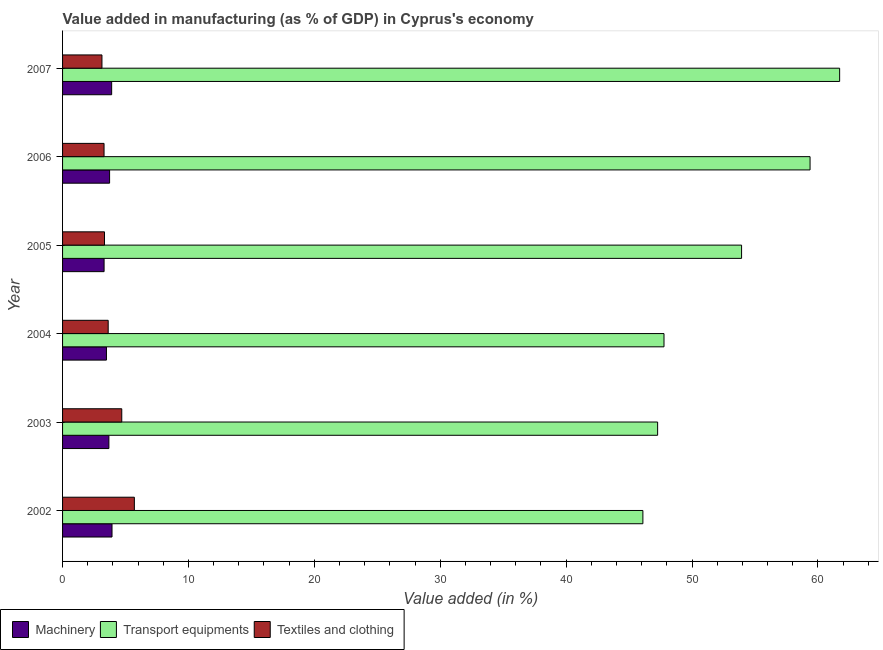How many groups of bars are there?
Provide a short and direct response. 6. Are the number of bars on each tick of the Y-axis equal?
Your answer should be very brief. Yes. What is the value added in manufacturing machinery in 2007?
Give a very brief answer. 3.9. Across all years, what is the maximum value added in manufacturing machinery?
Ensure brevity in your answer.  3.93. Across all years, what is the minimum value added in manufacturing machinery?
Your answer should be very brief. 3.3. In which year was the value added in manufacturing machinery maximum?
Your answer should be very brief. 2002. What is the total value added in manufacturing transport equipments in the graph?
Keep it short and to the point. 316.18. What is the difference between the value added in manufacturing machinery in 2002 and that in 2004?
Provide a short and direct response. 0.44. What is the difference between the value added in manufacturing machinery in 2002 and the value added in manufacturing textile and clothing in 2006?
Keep it short and to the point. 0.63. What is the average value added in manufacturing textile and clothing per year?
Keep it short and to the point. 3.96. In the year 2004, what is the difference between the value added in manufacturing transport equipments and value added in manufacturing textile and clothing?
Provide a succinct answer. 44.15. What is the ratio of the value added in manufacturing machinery in 2005 to that in 2007?
Provide a short and direct response. 0.85. Is the value added in manufacturing machinery in 2003 less than that in 2005?
Provide a short and direct response. No. Is the difference between the value added in manufacturing transport equipments in 2002 and 2005 greater than the difference between the value added in manufacturing machinery in 2002 and 2005?
Your answer should be very brief. No. What is the difference between the highest and the lowest value added in manufacturing transport equipments?
Your answer should be very brief. 15.63. In how many years, is the value added in manufacturing transport equipments greater than the average value added in manufacturing transport equipments taken over all years?
Offer a very short reply. 3. Is the sum of the value added in manufacturing machinery in 2002 and 2003 greater than the maximum value added in manufacturing textile and clothing across all years?
Provide a short and direct response. Yes. What does the 2nd bar from the top in 2007 represents?
Your answer should be very brief. Transport equipments. What does the 1st bar from the bottom in 2007 represents?
Ensure brevity in your answer.  Machinery. Is it the case that in every year, the sum of the value added in manufacturing machinery and value added in manufacturing transport equipments is greater than the value added in manufacturing textile and clothing?
Your response must be concise. Yes. How many bars are there?
Your answer should be compact. 18. Are all the bars in the graph horizontal?
Provide a short and direct response. Yes. How many years are there in the graph?
Provide a short and direct response. 6. What is the difference between two consecutive major ticks on the X-axis?
Give a very brief answer. 10. Does the graph contain any zero values?
Make the answer very short. No. Does the graph contain grids?
Provide a short and direct response. No. What is the title of the graph?
Make the answer very short. Value added in manufacturing (as % of GDP) in Cyprus's economy. What is the label or title of the X-axis?
Give a very brief answer. Value added (in %). What is the label or title of the Y-axis?
Provide a succinct answer. Year. What is the Value added (in %) in Machinery in 2002?
Keep it short and to the point. 3.93. What is the Value added (in %) of Transport equipments in 2002?
Offer a very short reply. 46.1. What is the Value added (in %) in Textiles and clothing in 2002?
Give a very brief answer. 5.7. What is the Value added (in %) of Machinery in 2003?
Offer a terse response. 3.68. What is the Value added (in %) in Transport equipments in 2003?
Provide a succinct answer. 47.27. What is the Value added (in %) of Textiles and clothing in 2003?
Your answer should be compact. 4.7. What is the Value added (in %) in Machinery in 2004?
Offer a very short reply. 3.49. What is the Value added (in %) of Transport equipments in 2004?
Provide a short and direct response. 47.78. What is the Value added (in %) of Textiles and clothing in 2004?
Offer a terse response. 3.62. What is the Value added (in %) in Machinery in 2005?
Your answer should be compact. 3.3. What is the Value added (in %) of Transport equipments in 2005?
Provide a short and direct response. 53.94. What is the Value added (in %) of Textiles and clothing in 2005?
Provide a short and direct response. 3.33. What is the Value added (in %) of Machinery in 2006?
Provide a succinct answer. 3.74. What is the Value added (in %) in Transport equipments in 2006?
Offer a very short reply. 59.38. What is the Value added (in %) in Textiles and clothing in 2006?
Provide a succinct answer. 3.29. What is the Value added (in %) in Machinery in 2007?
Provide a short and direct response. 3.9. What is the Value added (in %) in Transport equipments in 2007?
Ensure brevity in your answer.  61.73. What is the Value added (in %) of Textiles and clothing in 2007?
Give a very brief answer. 3.13. Across all years, what is the maximum Value added (in %) in Machinery?
Ensure brevity in your answer.  3.93. Across all years, what is the maximum Value added (in %) of Transport equipments?
Give a very brief answer. 61.73. Across all years, what is the maximum Value added (in %) of Textiles and clothing?
Your response must be concise. 5.7. Across all years, what is the minimum Value added (in %) in Machinery?
Your answer should be very brief. 3.3. Across all years, what is the minimum Value added (in %) in Transport equipments?
Provide a short and direct response. 46.1. Across all years, what is the minimum Value added (in %) in Textiles and clothing?
Provide a succinct answer. 3.13. What is the total Value added (in %) of Machinery in the graph?
Keep it short and to the point. 22.03. What is the total Value added (in %) of Transport equipments in the graph?
Provide a short and direct response. 316.18. What is the total Value added (in %) of Textiles and clothing in the graph?
Provide a succinct answer. 23.78. What is the difference between the Value added (in %) of Machinery in 2002 and that in 2003?
Your answer should be very brief. 0.25. What is the difference between the Value added (in %) of Transport equipments in 2002 and that in 2003?
Give a very brief answer. -1.17. What is the difference between the Value added (in %) in Machinery in 2002 and that in 2004?
Ensure brevity in your answer.  0.44. What is the difference between the Value added (in %) in Transport equipments in 2002 and that in 2004?
Make the answer very short. -1.68. What is the difference between the Value added (in %) in Textiles and clothing in 2002 and that in 2004?
Your response must be concise. 2.08. What is the difference between the Value added (in %) in Machinery in 2002 and that in 2005?
Keep it short and to the point. 0.63. What is the difference between the Value added (in %) in Transport equipments in 2002 and that in 2005?
Your response must be concise. -7.84. What is the difference between the Value added (in %) of Textiles and clothing in 2002 and that in 2005?
Give a very brief answer. 2.37. What is the difference between the Value added (in %) in Machinery in 2002 and that in 2006?
Ensure brevity in your answer.  0.19. What is the difference between the Value added (in %) of Transport equipments in 2002 and that in 2006?
Give a very brief answer. -13.28. What is the difference between the Value added (in %) in Textiles and clothing in 2002 and that in 2006?
Make the answer very short. 2.41. What is the difference between the Value added (in %) in Machinery in 2002 and that in 2007?
Provide a short and direct response. 0.03. What is the difference between the Value added (in %) of Transport equipments in 2002 and that in 2007?
Your answer should be very brief. -15.63. What is the difference between the Value added (in %) in Textiles and clothing in 2002 and that in 2007?
Provide a succinct answer. 2.58. What is the difference between the Value added (in %) in Machinery in 2003 and that in 2004?
Your response must be concise. 0.19. What is the difference between the Value added (in %) in Transport equipments in 2003 and that in 2004?
Your response must be concise. -0.51. What is the difference between the Value added (in %) of Textiles and clothing in 2003 and that in 2004?
Your answer should be very brief. 1.08. What is the difference between the Value added (in %) in Machinery in 2003 and that in 2005?
Give a very brief answer. 0.38. What is the difference between the Value added (in %) in Transport equipments in 2003 and that in 2005?
Offer a very short reply. -6.67. What is the difference between the Value added (in %) in Textiles and clothing in 2003 and that in 2005?
Ensure brevity in your answer.  1.37. What is the difference between the Value added (in %) of Machinery in 2003 and that in 2006?
Provide a short and direct response. -0.06. What is the difference between the Value added (in %) in Transport equipments in 2003 and that in 2006?
Provide a short and direct response. -12.11. What is the difference between the Value added (in %) in Textiles and clothing in 2003 and that in 2006?
Offer a terse response. 1.41. What is the difference between the Value added (in %) in Machinery in 2003 and that in 2007?
Offer a very short reply. -0.22. What is the difference between the Value added (in %) in Transport equipments in 2003 and that in 2007?
Your answer should be compact. -14.46. What is the difference between the Value added (in %) in Textiles and clothing in 2003 and that in 2007?
Provide a succinct answer. 1.57. What is the difference between the Value added (in %) in Machinery in 2004 and that in 2005?
Your response must be concise. 0.19. What is the difference between the Value added (in %) of Transport equipments in 2004 and that in 2005?
Your answer should be very brief. -6.16. What is the difference between the Value added (in %) of Textiles and clothing in 2004 and that in 2005?
Offer a very short reply. 0.29. What is the difference between the Value added (in %) of Machinery in 2004 and that in 2006?
Provide a succinct answer. -0.25. What is the difference between the Value added (in %) in Transport equipments in 2004 and that in 2006?
Your answer should be compact. -11.6. What is the difference between the Value added (in %) of Textiles and clothing in 2004 and that in 2006?
Your answer should be very brief. 0.33. What is the difference between the Value added (in %) of Machinery in 2004 and that in 2007?
Your answer should be compact. -0.41. What is the difference between the Value added (in %) of Transport equipments in 2004 and that in 2007?
Make the answer very short. -13.95. What is the difference between the Value added (in %) of Textiles and clothing in 2004 and that in 2007?
Provide a succinct answer. 0.5. What is the difference between the Value added (in %) in Machinery in 2005 and that in 2006?
Ensure brevity in your answer.  -0.44. What is the difference between the Value added (in %) of Transport equipments in 2005 and that in 2006?
Your answer should be compact. -5.44. What is the difference between the Value added (in %) in Textiles and clothing in 2005 and that in 2006?
Offer a terse response. 0.04. What is the difference between the Value added (in %) in Machinery in 2005 and that in 2007?
Your answer should be very brief. -0.6. What is the difference between the Value added (in %) in Transport equipments in 2005 and that in 2007?
Make the answer very short. -7.79. What is the difference between the Value added (in %) in Textiles and clothing in 2005 and that in 2007?
Your answer should be very brief. 0.2. What is the difference between the Value added (in %) in Machinery in 2006 and that in 2007?
Your answer should be compact. -0.16. What is the difference between the Value added (in %) of Transport equipments in 2006 and that in 2007?
Your response must be concise. -2.35. What is the difference between the Value added (in %) of Textiles and clothing in 2006 and that in 2007?
Your answer should be compact. 0.17. What is the difference between the Value added (in %) in Machinery in 2002 and the Value added (in %) in Transport equipments in 2003?
Offer a terse response. -43.34. What is the difference between the Value added (in %) in Machinery in 2002 and the Value added (in %) in Textiles and clothing in 2003?
Provide a short and direct response. -0.77. What is the difference between the Value added (in %) in Transport equipments in 2002 and the Value added (in %) in Textiles and clothing in 2003?
Provide a succinct answer. 41.4. What is the difference between the Value added (in %) in Machinery in 2002 and the Value added (in %) in Transport equipments in 2004?
Provide a succinct answer. -43.85. What is the difference between the Value added (in %) in Machinery in 2002 and the Value added (in %) in Textiles and clothing in 2004?
Your answer should be compact. 0.3. What is the difference between the Value added (in %) of Transport equipments in 2002 and the Value added (in %) of Textiles and clothing in 2004?
Provide a succinct answer. 42.47. What is the difference between the Value added (in %) in Machinery in 2002 and the Value added (in %) in Transport equipments in 2005?
Offer a terse response. -50.01. What is the difference between the Value added (in %) in Machinery in 2002 and the Value added (in %) in Textiles and clothing in 2005?
Provide a succinct answer. 0.6. What is the difference between the Value added (in %) of Transport equipments in 2002 and the Value added (in %) of Textiles and clothing in 2005?
Your answer should be very brief. 42.77. What is the difference between the Value added (in %) in Machinery in 2002 and the Value added (in %) in Transport equipments in 2006?
Make the answer very short. -55.45. What is the difference between the Value added (in %) in Machinery in 2002 and the Value added (in %) in Textiles and clothing in 2006?
Keep it short and to the point. 0.63. What is the difference between the Value added (in %) of Transport equipments in 2002 and the Value added (in %) of Textiles and clothing in 2006?
Provide a succinct answer. 42.8. What is the difference between the Value added (in %) of Machinery in 2002 and the Value added (in %) of Transport equipments in 2007?
Offer a terse response. -57.8. What is the difference between the Value added (in %) in Machinery in 2002 and the Value added (in %) in Textiles and clothing in 2007?
Offer a very short reply. 0.8. What is the difference between the Value added (in %) in Transport equipments in 2002 and the Value added (in %) in Textiles and clothing in 2007?
Provide a short and direct response. 42.97. What is the difference between the Value added (in %) of Machinery in 2003 and the Value added (in %) of Transport equipments in 2004?
Provide a succinct answer. -44.1. What is the difference between the Value added (in %) in Machinery in 2003 and the Value added (in %) in Textiles and clothing in 2004?
Give a very brief answer. 0.06. What is the difference between the Value added (in %) of Transport equipments in 2003 and the Value added (in %) of Textiles and clothing in 2004?
Offer a terse response. 43.64. What is the difference between the Value added (in %) of Machinery in 2003 and the Value added (in %) of Transport equipments in 2005?
Ensure brevity in your answer.  -50.26. What is the difference between the Value added (in %) of Machinery in 2003 and the Value added (in %) of Textiles and clothing in 2005?
Offer a terse response. 0.35. What is the difference between the Value added (in %) in Transport equipments in 2003 and the Value added (in %) in Textiles and clothing in 2005?
Keep it short and to the point. 43.94. What is the difference between the Value added (in %) of Machinery in 2003 and the Value added (in %) of Transport equipments in 2006?
Keep it short and to the point. -55.7. What is the difference between the Value added (in %) in Machinery in 2003 and the Value added (in %) in Textiles and clothing in 2006?
Keep it short and to the point. 0.38. What is the difference between the Value added (in %) in Transport equipments in 2003 and the Value added (in %) in Textiles and clothing in 2006?
Give a very brief answer. 43.97. What is the difference between the Value added (in %) of Machinery in 2003 and the Value added (in %) of Transport equipments in 2007?
Provide a short and direct response. -58.05. What is the difference between the Value added (in %) of Machinery in 2003 and the Value added (in %) of Textiles and clothing in 2007?
Offer a terse response. 0.55. What is the difference between the Value added (in %) in Transport equipments in 2003 and the Value added (in %) in Textiles and clothing in 2007?
Offer a very short reply. 44.14. What is the difference between the Value added (in %) in Machinery in 2004 and the Value added (in %) in Transport equipments in 2005?
Provide a succinct answer. -50.45. What is the difference between the Value added (in %) of Machinery in 2004 and the Value added (in %) of Textiles and clothing in 2005?
Offer a terse response. 0.16. What is the difference between the Value added (in %) in Transport equipments in 2004 and the Value added (in %) in Textiles and clothing in 2005?
Keep it short and to the point. 44.44. What is the difference between the Value added (in %) of Machinery in 2004 and the Value added (in %) of Transport equipments in 2006?
Provide a short and direct response. -55.89. What is the difference between the Value added (in %) in Machinery in 2004 and the Value added (in %) in Textiles and clothing in 2006?
Provide a succinct answer. 0.19. What is the difference between the Value added (in %) of Transport equipments in 2004 and the Value added (in %) of Textiles and clothing in 2006?
Offer a terse response. 44.48. What is the difference between the Value added (in %) of Machinery in 2004 and the Value added (in %) of Transport equipments in 2007?
Offer a very short reply. -58.24. What is the difference between the Value added (in %) of Machinery in 2004 and the Value added (in %) of Textiles and clothing in 2007?
Ensure brevity in your answer.  0.36. What is the difference between the Value added (in %) in Transport equipments in 2004 and the Value added (in %) in Textiles and clothing in 2007?
Provide a succinct answer. 44.65. What is the difference between the Value added (in %) of Machinery in 2005 and the Value added (in %) of Transport equipments in 2006?
Offer a terse response. -56.08. What is the difference between the Value added (in %) in Machinery in 2005 and the Value added (in %) in Textiles and clothing in 2006?
Your answer should be compact. 0. What is the difference between the Value added (in %) in Transport equipments in 2005 and the Value added (in %) in Textiles and clothing in 2006?
Offer a very short reply. 50.64. What is the difference between the Value added (in %) of Machinery in 2005 and the Value added (in %) of Transport equipments in 2007?
Ensure brevity in your answer.  -58.43. What is the difference between the Value added (in %) in Machinery in 2005 and the Value added (in %) in Textiles and clothing in 2007?
Give a very brief answer. 0.17. What is the difference between the Value added (in %) in Transport equipments in 2005 and the Value added (in %) in Textiles and clothing in 2007?
Your response must be concise. 50.81. What is the difference between the Value added (in %) of Machinery in 2006 and the Value added (in %) of Transport equipments in 2007?
Offer a very short reply. -57.99. What is the difference between the Value added (in %) in Machinery in 2006 and the Value added (in %) in Textiles and clothing in 2007?
Offer a very short reply. 0.61. What is the difference between the Value added (in %) of Transport equipments in 2006 and the Value added (in %) of Textiles and clothing in 2007?
Provide a succinct answer. 56.25. What is the average Value added (in %) in Machinery per year?
Your answer should be very brief. 3.67. What is the average Value added (in %) in Transport equipments per year?
Give a very brief answer. 52.7. What is the average Value added (in %) in Textiles and clothing per year?
Ensure brevity in your answer.  3.96. In the year 2002, what is the difference between the Value added (in %) of Machinery and Value added (in %) of Transport equipments?
Your answer should be compact. -42.17. In the year 2002, what is the difference between the Value added (in %) of Machinery and Value added (in %) of Textiles and clothing?
Offer a very short reply. -1.78. In the year 2002, what is the difference between the Value added (in %) of Transport equipments and Value added (in %) of Textiles and clothing?
Ensure brevity in your answer.  40.39. In the year 2003, what is the difference between the Value added (in %) of Machinery and Value added (in %) of Transport equipments?
Offer a very short reply. -43.59. In the year 2003, what is the difference between the Value added (in %) in Machinery and Value added (in %) in Textiles and clothing?
Give a very brief answer. -1.02. In the year 2003, what is the difference between the Value added (in %) of Transport equipments and Value added (in %) of Textiles and clothing?
Provide a succinct answer. 42.57. In the year 2004, what is the difference between the Value added (in %) in Machinery and Value added (in %) in Transport equipments?
Your answer should be compact. -44.29. In the year 2004, what is the difference between the Value added (in %) of Machinery and Value added (in %) of Textiles and clothing?
Give a very brief answer. -0.14. In the year 2004, what is the difference between the Value added (in %) of Transport equipments and Value added (in %) of Textiles and clothing?
Your answer should be very brief. 44.15. In the year 2005, what is the difference between the Value added (in %) in Machinery and Value added (in %) in Transport equipments?
Provide a short and direct response. -50.64. In the year 2005, what is the difference between the Value added (in %) of Machinery and Value added (in %) of Textiles and clothing?
Give a very brief answer. -0.03. In the year 2005, what is the difference between the Value added (in %) of Transport equipments and Value added (in %) of Textiles and clothing?
Offer a very short reply. 50.61. In the year 2006, what is the difference between the Value added (in %) of Machinery and Value added (in %) of Transport equipments?
Provide a short and direct response. -55.64. In the year 2006, what is the difference between the Value added (in %) in Machinery and Value added (in %) in Textiles and clothing?
Keep it short and to the point. 0.44. In the year 2006, what is the difference between the Value added (in %) of Transport equipments and Value added (in %) of Textiles and clothing?
Ensure brevity in your answer.  56.08. In the year 2007, what is the difference between the Value added (in %) in Machinery and Value added (in %) in Transport equipments?
Give a very brief answer. -57.83. In the year 2007, what is the difference between the Value added (in %) in Machinery and Value added (in %) in Textiles and clothing?
Your answer should be very brief. 0.77. In the year 2007, what is the difference between the Value added (in %) in Transport equipments and Value added (in %) in Textiles and clothing?
Ensure brevity in your answer.  58.6. What is the ratio of the Value added (in %) in Machinery in 2002 to that in 2003?
Provide a succinct answer. 1.07. What is the ratio of the Value added (in %) in Transport equipments in 2002 to that in 2003?
Provide a succinct answer. 0.98. What is the ratio of the Value added (in %) of Textiles and clothing in 2002 to that in 2003?
Your response must be concise. 1.21. What is the ratio of the Value added (in %) of Machinery in 2002 to that in 2004?
Give a very brief answer. 1.13. What is the ratio of the Value added (in %) of Transport equipments in 2002 to that in 2004?
Make the answer very short. 0.96. What is the ratio of the Value added (in %) of Textiles and clothing in 2002 to that in 2004?
Your answer should be very brief. 1.57. What is the ratio of the Value added (in %) in Machinery in 2002 to that in 2005?
Give a very brief answer. 1.19. What is the ratio of the Value added (in %) of Transport equipments in 2002 to that in 2005?
Ensure brevity in your answer.  0.85. What is the ratio of the Value added (in %) in Textiles and clothing in 2002 to that in 2005?
Offer a very short reply. 1.71. What is the ratio of the Value added (in %) of Machinery in 2002 to that in 2006?
Provide a short and direct response. 1.05. What is the ratio of the Value added (in %) in Transport equipments in 2002 to that in 2006?
Your response must be concise. 0.78. What is the ratio of the Value added (in %) of Textiles and clothing in 2002 to that in 2006?
Offer a terse response. 1.73. What is the ratio of the Value added (in %) of Machinery in 2002 to that in 2007?
Your answer should be very brief. 1.01. What is the ratio of the Value added (in %) in Transport equipments in 2002 to that in 2007?
Keep it short and to the point. 0.75. What is the ratio of the Value added (in %) in Textiles and clothing in 2002 to that in 2007?
Provide a succinct answer. 1.82. What is the ratio of the Value added (in %) of Machinery in 2003 to that in 2004?
Provide a succinct answer. 1.06. What is the ratio of the Value added (in %) of Transport equipments in 2003 to that in 2004?
Provide a succinct answer. 0.99. What is the ratio of the Value added (in %) of Textiles and clothing in 2003 to that in 2004?
Offer a terse response. 1.3. What is the ratio of the Value added (in %) of Machinery in 2003 to that in 2005?
Provide a short and direct response. 1.12. What is the ratio of the Value added (in %) in Transport equipments in 2003 to that in 2005?
Provide a short and direct response. 0.88. What is the ratio of the Value added (in %) in Textiles and clothing in 2003 to that in 2005?
Provide a short and direct response. 1.41. What is the ratio of the Value added (in %) in Machinery in 2003 to that in 2006?
Provide a short and direct response. 0.99. What is the ratio of the Value added (in %) of Transport equipments in 2003 to that in 2006?
Make the answer very short. 0.8. What is the ratio of the Value added (in %) in Textiles and clothing in 2003 to that in 2006?
Make the answer very short. 1.43. What is the ratio of the Value added (in %) in Machinery in 2003 to that in 2007?
Offer a very short reply. 0.94. What is the ratio of the Value added (in %) in Transport equipments in 2003 to that in 2007?
Your answer should be very brief. 0.77. What is the ratio of the Value added (in %) of Textiles and clothing in 2003 to that in 2007?
Provide a succinct answer. 1.5. What is the ratio of the Value added (in %) in Machinery in 2004 to that in 2005?
Your response must be concise. 1.06. What is the ratio of the Value added (in %) of Transport equipments in 2004 to that in 2005?
Provide a succinct answer. 0.89. What is the ratio of the Value added (in %) of Textiles and clothing in 2004 to that in 2005?
Provide a succinct answer. 1.09. What is the ratio of the Value added (in %) of Machinery in 2004 to that in 2006?
Keep it short and to the point. 0.93. What is the ratio of the Value added (in %) of Transport equipments in 2004 to that in 2006?
Provide a short and direct response. 0.8. What is the ratio of the Value added (in %) of Machinery in 2004 to that in 2007?
Your answer should be very brief. 0.89. What is the ratio of the Value added (in %) in Transport equipments in 2004 to that in 2007?
Provide a succinct answer. 0.77. What is the ratio of the Value added (in %) in Textiles and clothing in 2004 to that in 2007?
Give a very brief answer. 1.16. What is the ratio of the Value added (in %) in Machinery in 2005 to that in 2006?
Your response must be concise. 0.88. What is the ratio of the Value added (in %) in Transport equipments in 2005 to that in 2006?
Make the answer very short. 0.91. What is the ratio of the Value added (in %) of Machinery in 2005 to that in 2007?
Give a very brief answer. 0.85. What is the ratio of the Value added (in %) of Transport equipments in 2005 to that in 2007?
Provide a succinct answer. 0.87. What is the ratio of the Value added (in %) of Textiles and clothing in 2005 to that in 2007?
Give a very brief answer. 1.06. What is the ratio of the Value added (in %) of Machinery in 2006 to that in 2007?
Your response must be concise. 0.96. What is the ratio of the Value added (in %) in Transport equipments in 2006 to that in 2007?
Ensure brevity in your answer.  0.96. What is the ratio of the Value added (in %) in Textiles and clothing in 2006 to that in 2007?
Provide a short and direct response. 1.05. What is the difference between the highest and the second highest Value added (in %) in Machinery?
Ensure brevity in your answer.  0.03. What is the difference between the highest and the second highest Value added (in %) of Transport equipments?
Keep it short and to the point. 2.35. What is the difference between the highest and the second highest Value added (in %) in Textiles and clothing?
Provide a short and direct response. 1. What is the difference between the highest and the lowest Value added (in %) of Machinery?
Keep it short and to the point. 0.63. What is the difference between the highest and the lowest Value added (in %) of Transport equipments?
Your answer should be compact. 15.63. What is the difference between the highest and the lowest Value added (in %) in Textiles and clothing?
Offer a very short reply. 2.58. 